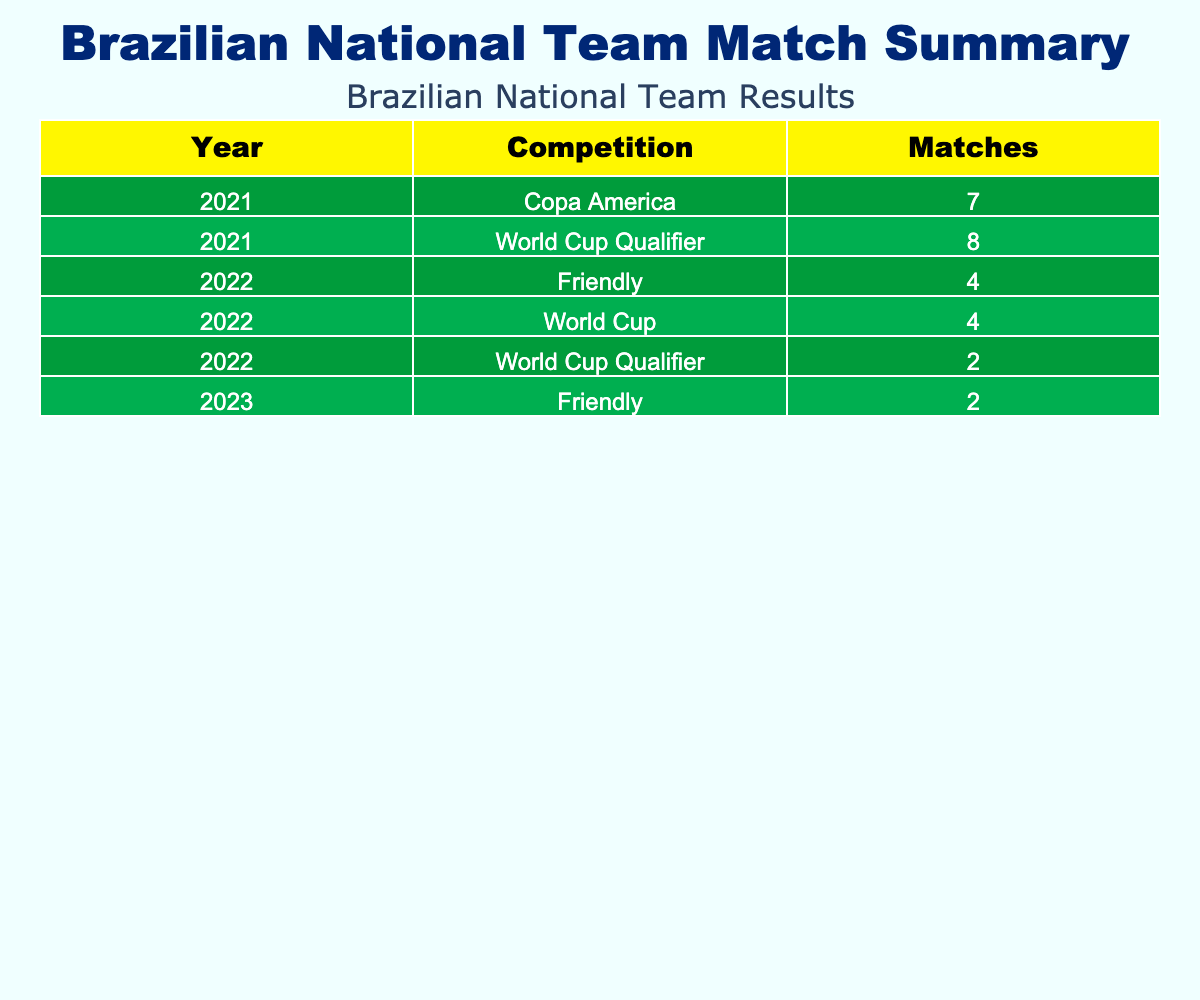What was the result of the Brazilian national team's match against Guinea? The result is shown as "W 4-1" in the relevant row of the table, indicating that Brazil won the match with a score of 4 to 1.
Answer: W 4-1 How many matches did Brazil play in the year 2021? By counting the entries for the year 2021 in the table, there are 10 matches listed for that year.
Answer: 10 Did Brazil win all their World Cup Qualifier matches in 2022? In the 2022 World Cup Qualifier entries, Brazil won three matches (against Bolivia, Chile, and Colombia) and drew one match (against Argentina). Since they did not win all, the answer is no.
Answer: No What is the total number of goals scored by Brazil in matches against Peru in the table? Brazil's matches against Peru are located in two entries: one match occurred during Copa America with a score of 1-0 and another match in a World Cup Qualifier. In that qualifier, the score was 3-1, resulting in a total of (1 + 3) = 4 goals scored in total.
Answer: 4 Which competition had the most matches played by Brazil in 2021? The competitions for 2021 include World Cup Qualifiers and Copa America. Counting matches, Brazil played 8 matches in the World Cup Qualifiers while they played 4 matches in the Copa America. Therefore, the World Cup Qualifiers had the most matches played.
Answer: World Cup Qualifiers How many players scored in the match against South Korea in the World Cup? In the match against South Korea on December 5, 2022, a total of 3 goals were scored by different players – Vinicius Jr., Neymar, and Richarlison.
Answer: 3 What was Brazil's overall win-loss record against Chile in the matches listed? Brazil played two matches against Chile listed in the table, winning one (4-0) and winning another (1-0). Therefore, the overall record against Chile is 2 wins and 0 losses.
Answer: 2 wins, 0 losses Did Neymar score in the most recent match listed for Brazil? In the most recent entry for Brazil against Guinea, Neymar is listed among the goal scorers with 1 goal. Therefore, yes, Neymar scored in this match.
Answer: Yes In which competition did Brazil experience its only loss in the year 2021 according to the table? In the year 2021, Brazil had a match listed in the Copa America against Argentina, which they lost (0-1). This was their only loss that year according to the data.
Answer: Copa America 